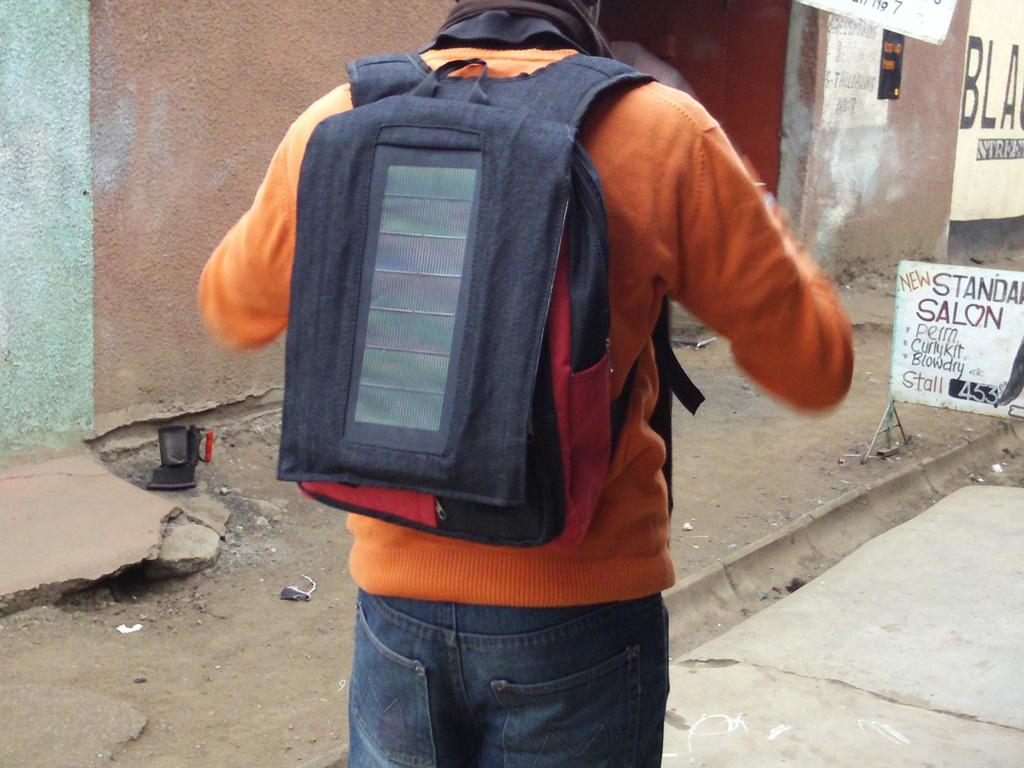What is the person in the image doing? The person is standing on the road. What is the person carrying or wearing? The person is wearing a bag. What is in front of the person? There is a sign board and a wall in front of the person. Can you see any islands in the image? There are no islands present in the image; it features a person standing on a road with a sign board and a wall in front of them. Is there a judge visible in the image? There is no judge present in the image. 